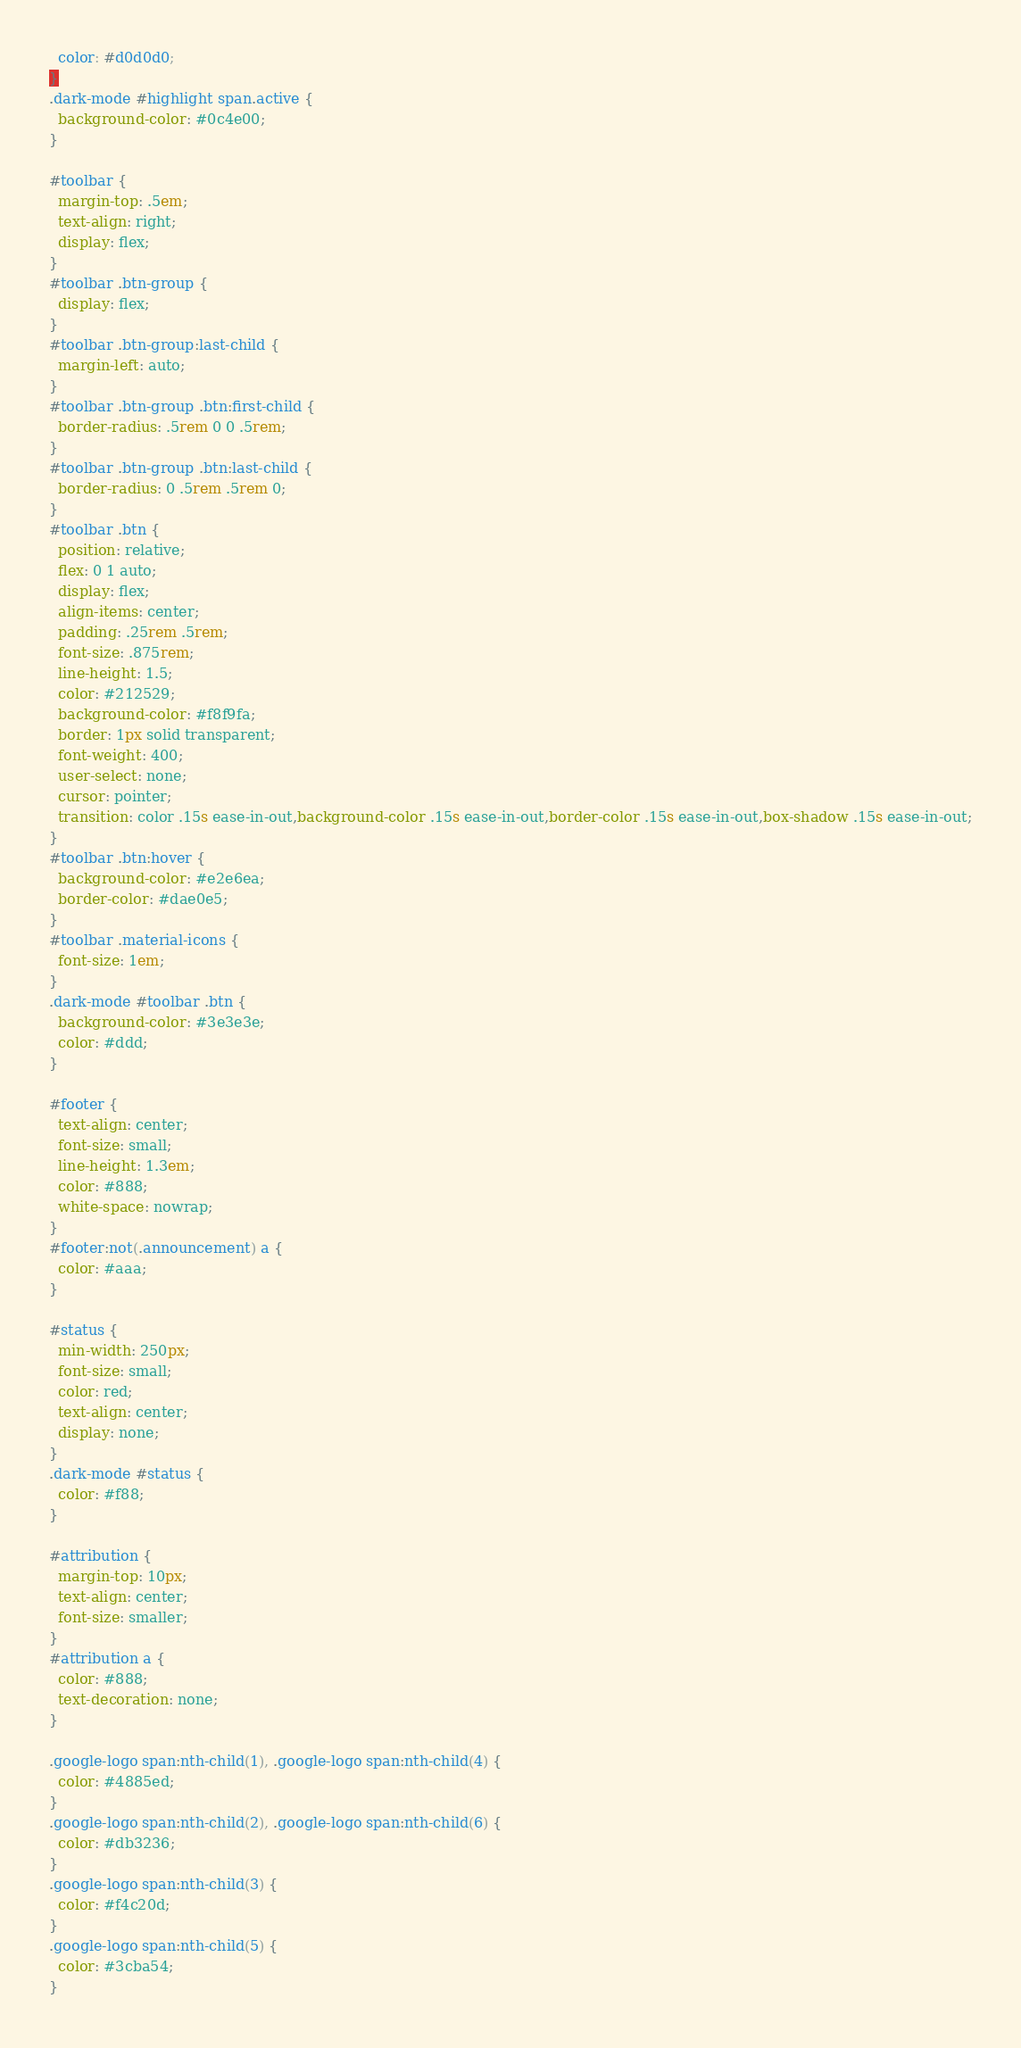Convert code to text. <code><loc_0><loc_0><loc_500><loc_500><_CSS_>  color: #d0d0d0;
}
.dark-mode #highlight span.active {
  background-color: #0c4e00;
}

#toolbar {
  margin-top: .5em;
  text-align: right;
  display: flex;
}
#toolbar .btn-group {
  display: flex;
}
#toolbar .btn-group:last-child {
  margin-left: auto;
}
#toolbar .btn-group .btn:first-child {
  border-radius: .5rem 0 0 .5rem;
}
#toolbar .btn-group .btn:last-child {
  border-radius: 0 .5rem .5rem 0;
}
#toolbar .btn {
  position: relative;
  flex: 0 1 auto;
  display: flex;
  align-items: center;
  padding: .25rem .5rem;
  font-size: .875rem;
  line-height: 1.5;
  color: #212529;
  background-color: #f8f9fa;
  border: 1px solid transparent;
  font-weight: 400;
  user-select: none;
  cursor: pointer;
  transition: color .15s ease-in-out,background-color .15s ease-in-out,border-color .15s ease-in-out,box-shadow .15s ease-in-out;
}
#toolbar .btn:hover {
  background-color: #e2e6ea;
  border-color: #dae0e5;
}
#toolbar .material-icons {
  font-size: 1em;
}
.dark-mode #toolbar .btn {
  background-color: #3e3e3e;
  color: #ddd;
}

#footer {
  text-align: center;
  font-size: small;
  line-height: 1.3em;
  color: #888;
  white-space: nowrap;
}
#footer:not(.announcement) a {
  color: #aaa;
}

#status {
  min-width: 250px;
  font-size: small;
  color: red;
  text-align: center;
  display: none;
}
.dark-mode #status {
  color: #f88;
}

#attribution {
  margin-top: 10px;
  text-align: center;
  font-size: smaller;
}
#attribution a {
  color: #888;
  text-decoration: none;
}

.google-logo span:nth-child(1), .google-logo span:nth-child(4) {
  color: #4885ed;
}
.google-logo span:nth-child(2), .google-logo span:nth-child(6) {
  color: #db3236;
}
.google-logo span:nth-child(3) {
  color: #f4c20d;
}
.google-logo span:nth-child(5) {
  color: #3cba54;
}
</code> 